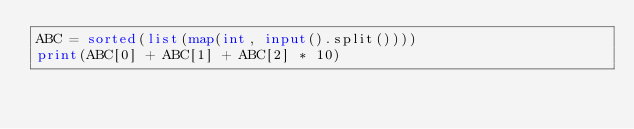Convert code to text. <code><loc_0><loc_0><loc_500><loc_500><_Python_>ABC = sorted(list(map(int, input().split())))
print(ABC[0] + ABC[1] + ABC[2] * 10)</code> 